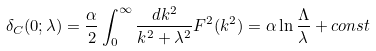<formula> <loc_0><loc_0><loc_500><loc_500>\delta _ { C } ( 0 ; \lambda ) = \frac { \alpha } { 2 } \int _ { 0 } ^ { \infty } \frac { d k ^ { 2 } } { k ^ { 2 } + \lambda ^ { 2 } } F ^ { 2 } ( k ^ { 2 } ) = \alpha \ln \frac { \Lambda } { \lambda } + c o n s t</formula> 